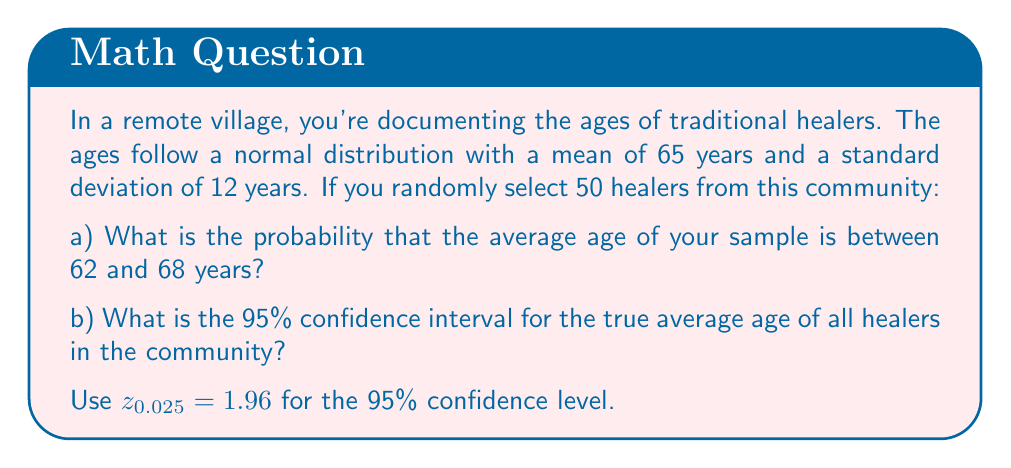Can you answer this question? Let's approach this step-by-step:

a) To find the probability that the sample mean is between 62 and 68 years:

1. We know that the sampling distribution of the mean follows a normal distribution with:
   $$\mu_{\bar{X}} = \mu = 65$$
   $$\sigma_{\bar{X}} = \frac{\sigma}{\sqrt{n}} = \frac{12}{\sqrt{50}} = 1.697$$

2. We need to calculate the z-scores for 62 and 68:
   $$z_{62} = \frac{62 - 65}{1.697} = -1.77$$
   $$z_{68} = \frac{68 - 65}{1.697} = 1.77$$

3. Using the standard normal distribution table or calculator:
   $$P(62 < \bar{X} < 68) = P(-1.77 < Z < 1.77) = 0.9234 - (1 - 0.9234) = 0.8468$$

b) For the 95% confidence interval:

1. The formula is: $\bar{X} \pm z_{0.025} \cdot \frac{\sigma}{\sqrt{n}}$

2. We don't have a sample, so we use the population mean:
   $$65 \pm 1.96 \cdot \frac{12}{\sqrt{50}}$$

3. Calculating:
   $$65 \pm 1.96 \cdot 1.697 = 65 \pm 3.33$$

   So, the interval is (61.67, 68.33)
Answer: a) 0.8468
b) (61.67, 68.33) 